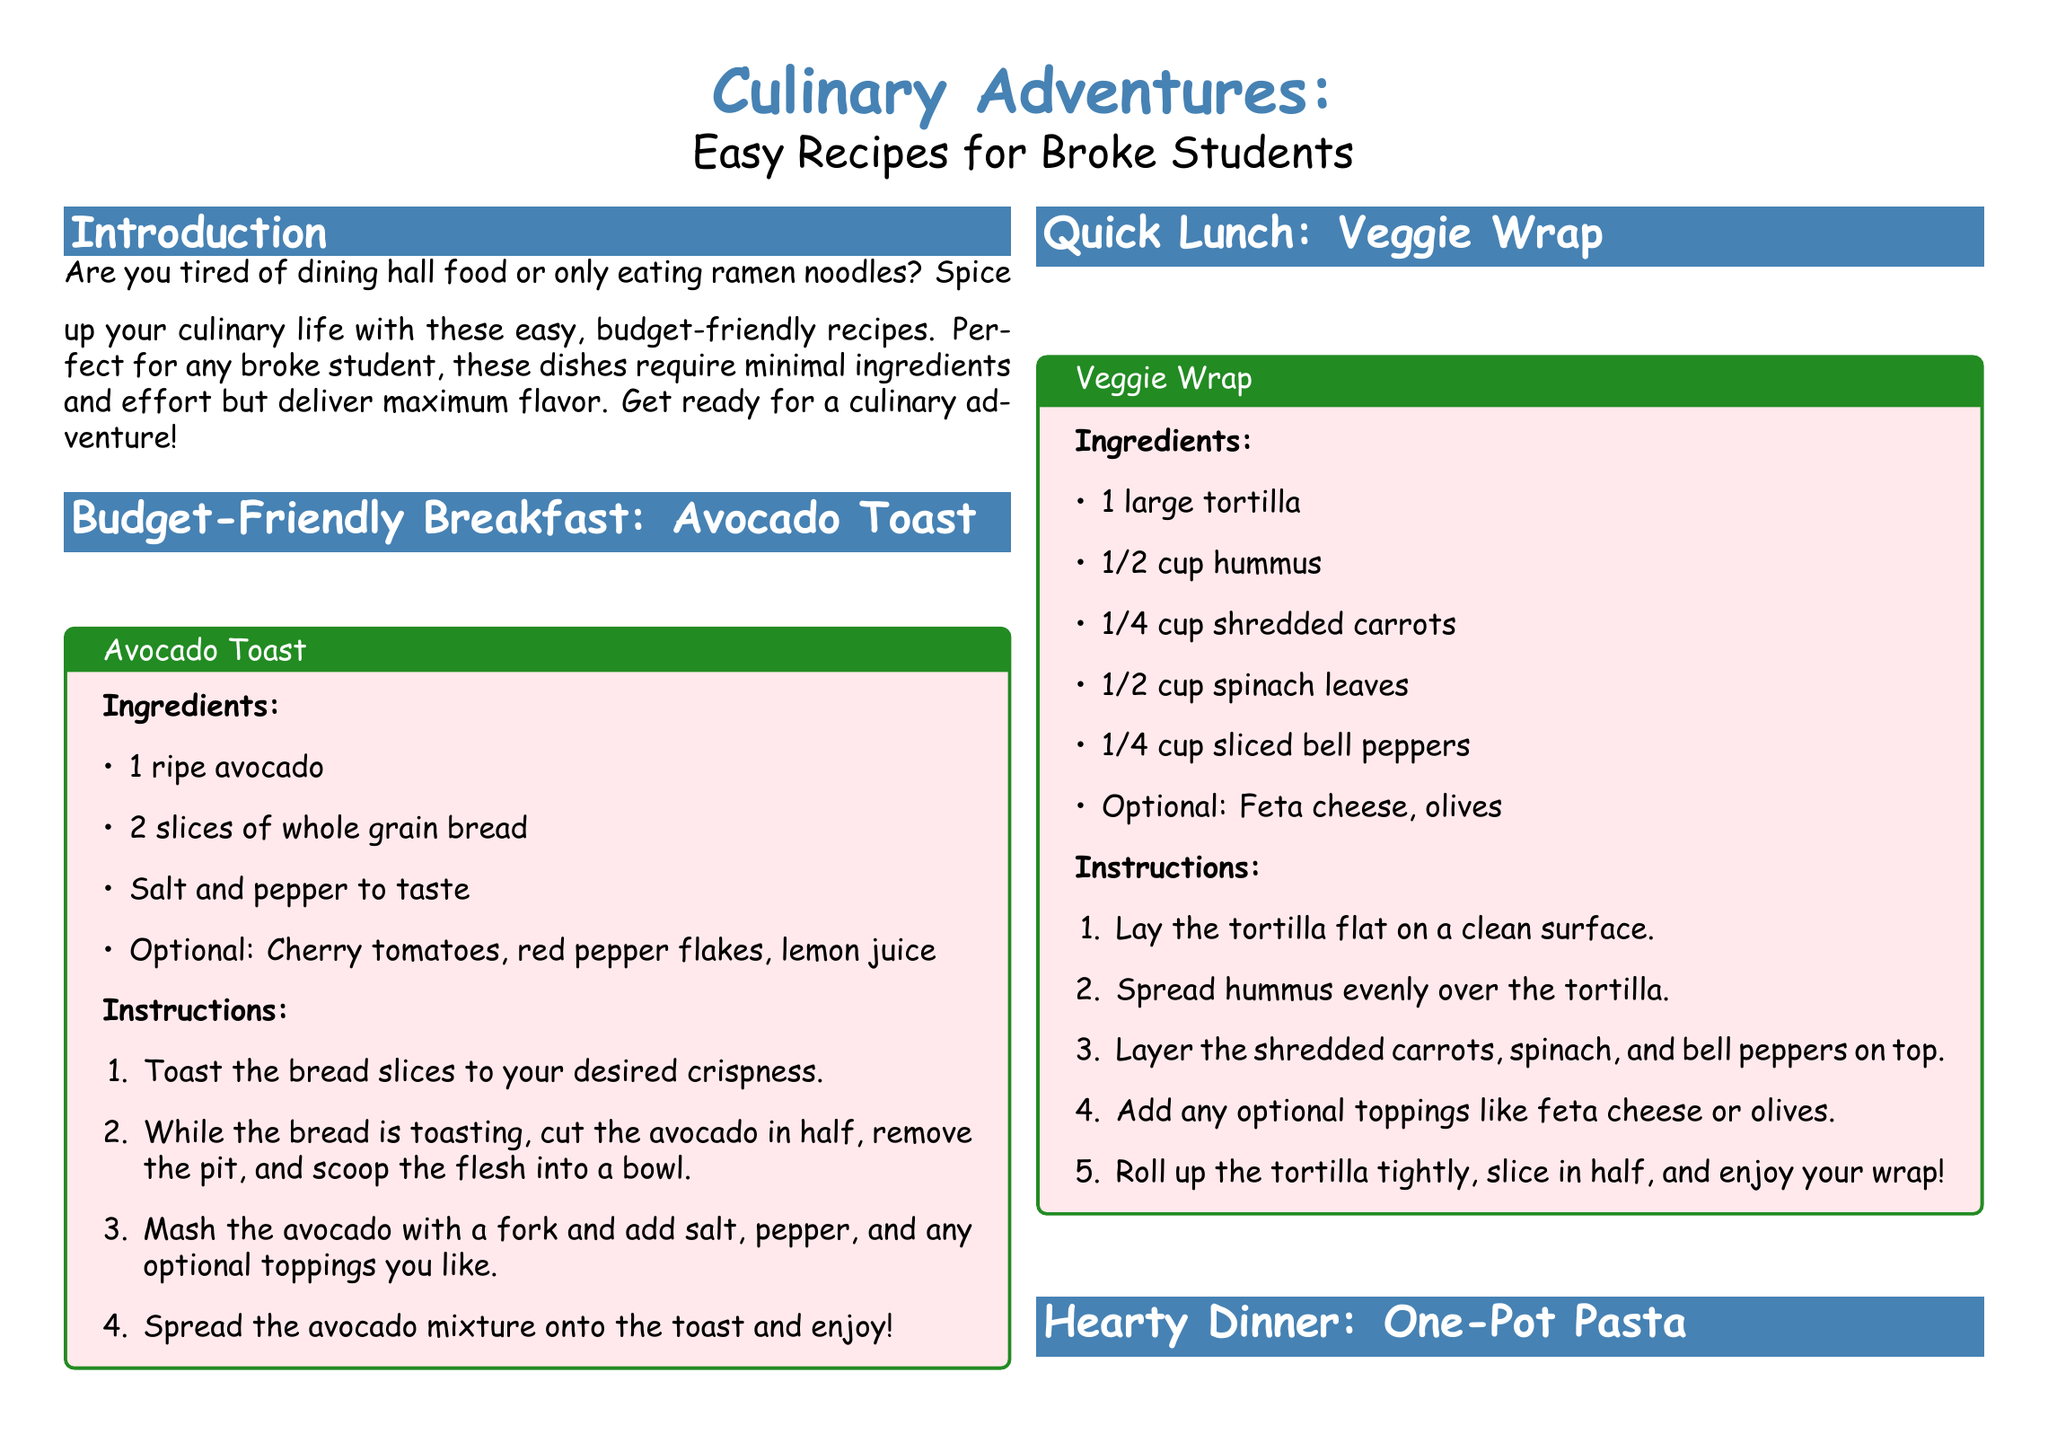What is the title of the magazine spread? The title of the magazine spread is prominently displayed at the top of the document, introducing the theme of budget-friendly recipes.
Answer: Culinary Adventures: Easy Recipes for Broke Students How many recipes are provided in the document? The document lists four complete recipes under different categories, such as breakfast, lunch, dinner, and dessert.
Answer: Four What is the first recipe listed? The first recipe given in the document is a breakfast option that is presented to entice beginners looking for quick and easy meals.
Answer: Avocado Toast What is the total ingredient count for the One-Pot Pasta recipe? The ingredient list for the One-Pot Pasta recipe contains eight specific items needed to prepare the dish.
Answer: Eight What optional ingredients can be added to the Microwave Mug Cake? The optional additions to enhance the flavor of the Microwave Mug Cake are mentioned in the recipe, suggesting ways to customize the dish.
Answer: Chocolate chips, vanilla ice cream What cooking method is used for the Microwave Mug Cake? The specific method indicated for preparing the Microwave Mug Cake is designed for quick preparation and minimal cleanup.
Answer: Microwave Which meal category does the Veggie Wrap belong to? The Veggie Wrap recipe is categorized under a specific meal type, typically associated with convenience and ease of assembly.
Answer: Quick Lunch What color is used for the recipe box background in the document? The color choice for the recipe box background is specified in the styling of the document, contributing to its overall vibrant aesthetic.
Answer: Pink 